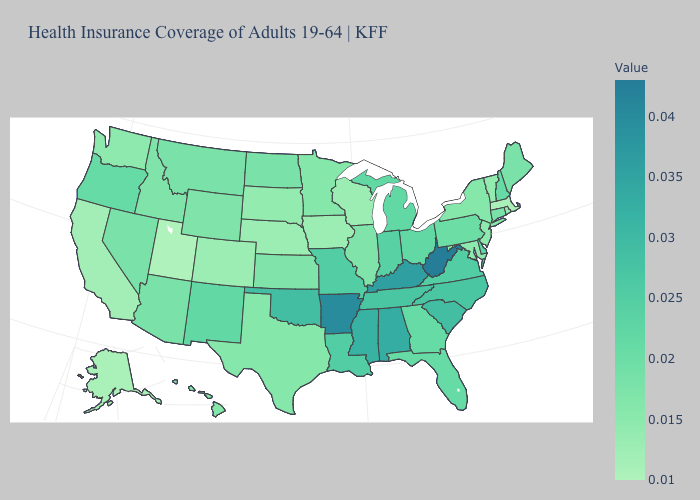Does the map have missing data?
Write a very short answer. No. Does Massachusetts have the lowest value in the Northeast?
Short answer required. Yes. Does Washington have the highest value in the USA?
Concise answer only. No. Which states hav the highest value in the MidWest?
Be succinct. Missouri. Which states have the lowest value in the USA?
Keep it brief. Utah. 